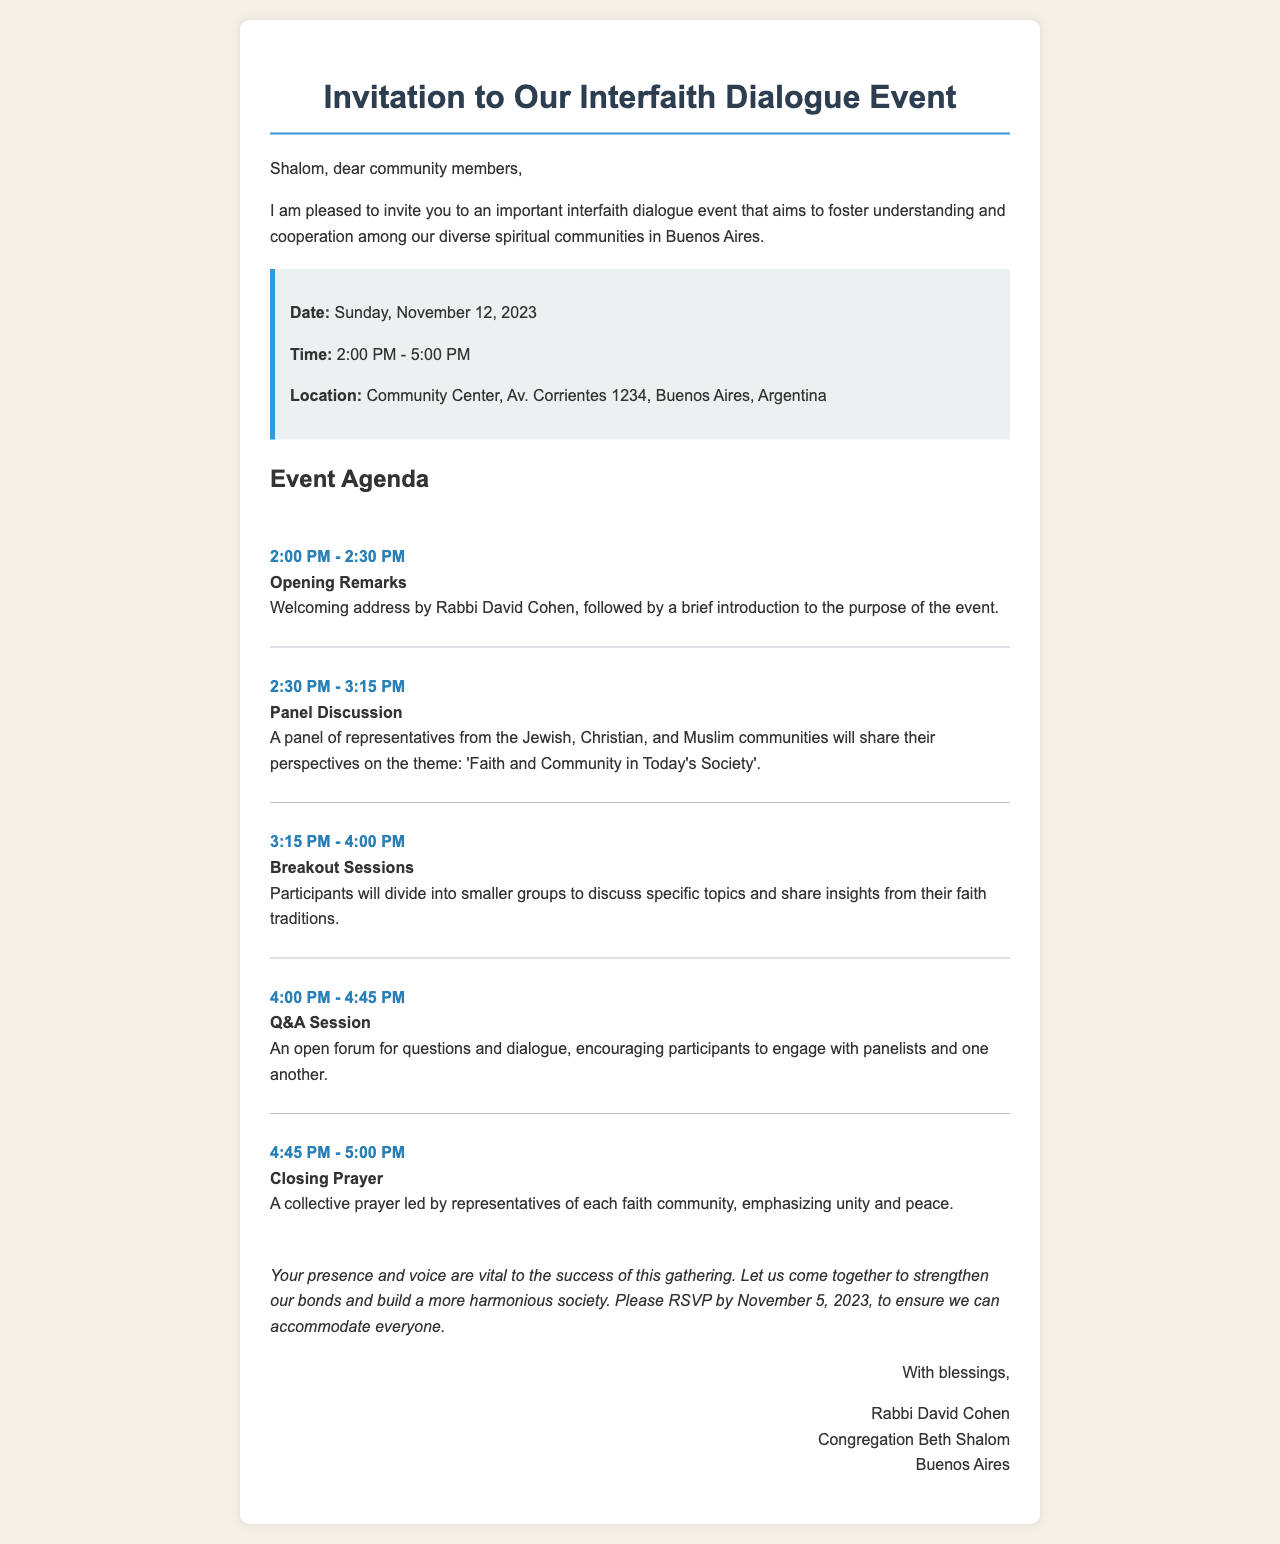what is the date of the event? The date of the event is specifically mentioned in the document.
Answer: Sunday, November 12, 2023 what time does the event start? The document provides the starting time for the event.
Answer: 2:00 PM where will the event take place? The location of the event is clearly stated in the document.
Answer: Community Center, Av. Corrientes 1234, Buenos Aires, Argentina who will give the opening remarks? The document indicates who is responsible for the opening remarks at the event.
Answer: Rabbi David Cohen what is the theme of the panel discussion? The document reveals the topic of the panel discussion segment.
Answer: Faith and Community in Today's Society how many agenda items are listed for the event? The total number of agenda items can be counted from the agenda section of the document.
Answer: 5 when is the RSVP deadline? The document specifies the deadline for participants to RSVP.
Answer: November 5, 2023 what is the purpose of the closing prayer? The document describes the intent behind the closing prayer at the event.
Answer: Emphasizing unity and peace what type of session follows the panel discussion? The document outlines the order of activities during the event.
Answer: Breakout Sessions 